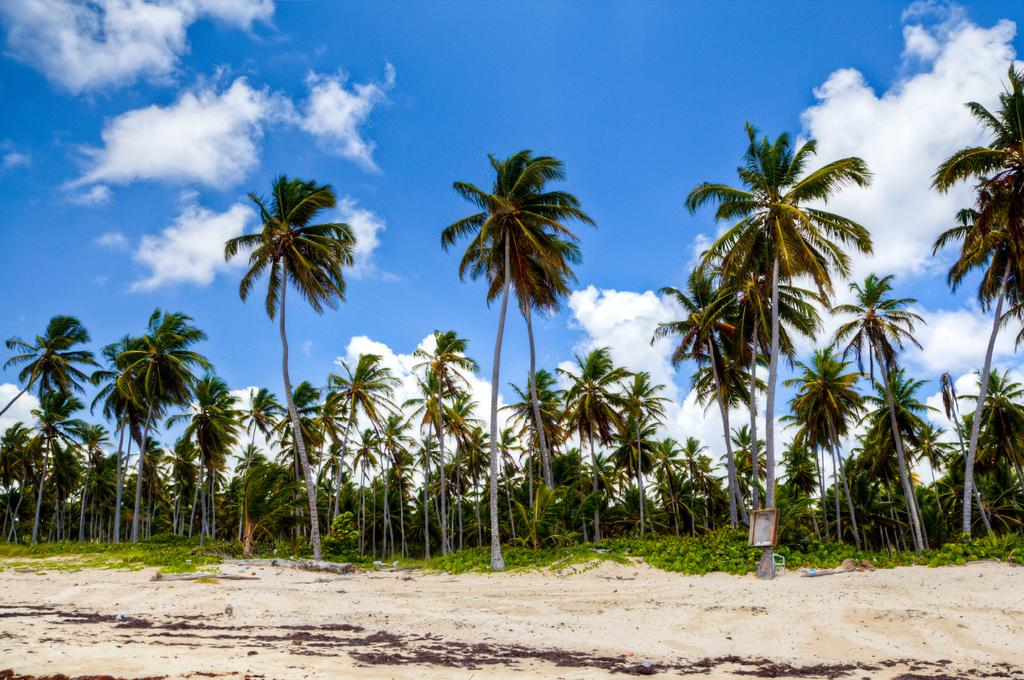What type of vegetation is in the center of the image? There are trees in the center of the image. What type of terrain is at the bottom of the image? There is sand at the bottom of the image. What is visible at the top of the image? The sky is visible at the top of the image. Where is the library located in the image? There is no library present in the image. How many pigs can be seen playing in the sand in the image? There are no pigs present in the image; it features trees and sand. 